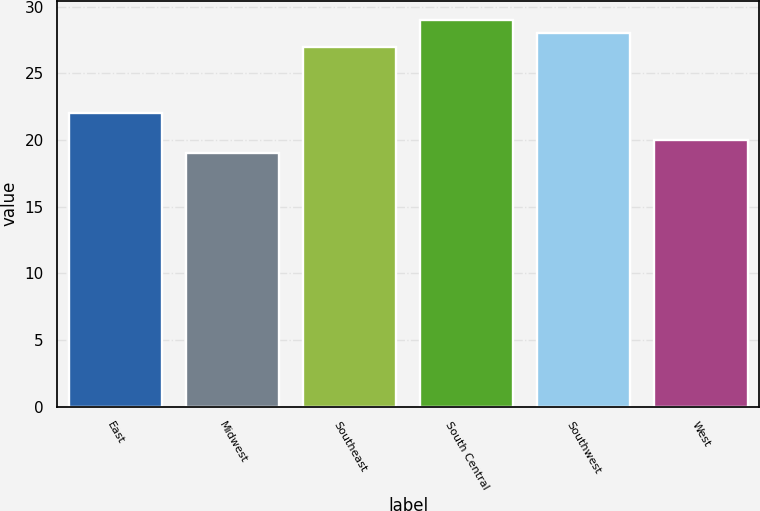<chart> <loc_0><loc_0><loc_500><loc_500><bar_chart><fcel>East<fcel>Midwest<fcel>Southeast<fcel>South Central<fcel>Southwest<fcel>West<nl><fcel>22<fcel>19<fcel>27<fcel>29<fcel>28<fcel>20<nl></chart> 